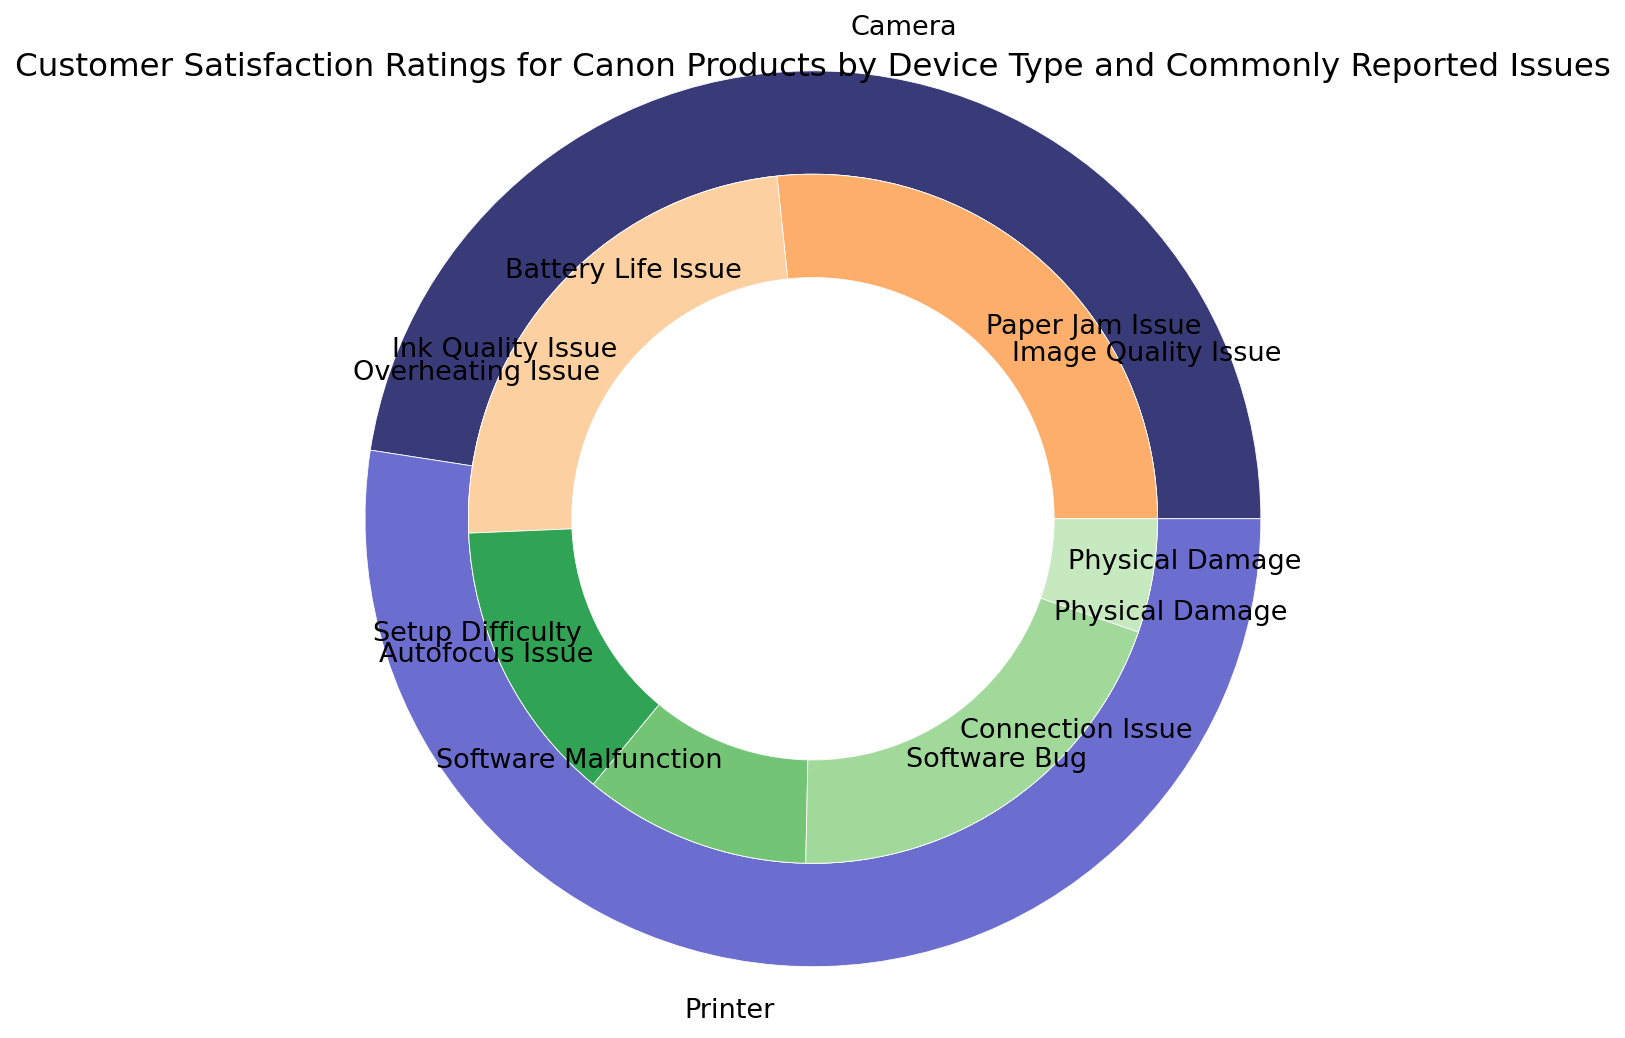Which device type has the higher overall percentage of issues reported? By looking at the outer ring, it is clear that the sector for "Printer" is larger than "Camera," indicating that Printers have a higher overall percentage of issues reported.
Answer: Printer Which issue has the lowest customer satisfaction rating among printers? On the inner ring for printers, the sector labeled "Physical Damage" appears, and it has the smallest portion in terms of percentages, correlating to the lowest customer satisfaction score.
Answer: Physical Damage What is the most commonly reported issue for cameras? In the inner ring for cameras, the sector for "Autofocus Issue" is the largest, representing the highest percentage of issues reported for cameras.
Answer: Autofocus Issue What percentage of the overall issues reported for Canon products is due to "Paper Jam Issue" in printers? To find this, look at the specific percentage labeled for "Paper Jam Issue" on the inner ring for printers. It states 20%.
Answer: 20% Which device type has a greater variety of reported issues? Count the number of distinct issues for each device type. Cameras have 6 distinct issues, and printers have 6 as well. Both device types have the same variety of reported issues.
Answer: Equal What is the difference in the percentage of issues reported for "Physical Damage" between cameras and printers? Subtract the percentage of "Physical Damage" issues for printers from the percentage for cameras. Cameras: 8% Printers: 4% Difference: 8% - 4% = 4%
Answer: 4% Which device type and issue combination has the highest customer satisfaction rating? By checking the inner ring for both device types, the sector labeled "Software Bug" under the cameras category has the highest customer satisfaction rating at 8.5.
Answer: Camera, Software Bug Is the percentage of "Software Bug" issues in cameras higher or lower than "Connection Issue" in printers? Compare the labeled percentages: "Software Bug" in cameras is 10%, and "Connection Issue" in printers is 15%. "Software Bug" in cameras is lower than "Connection Issue" in printers.
Answer: Lower 